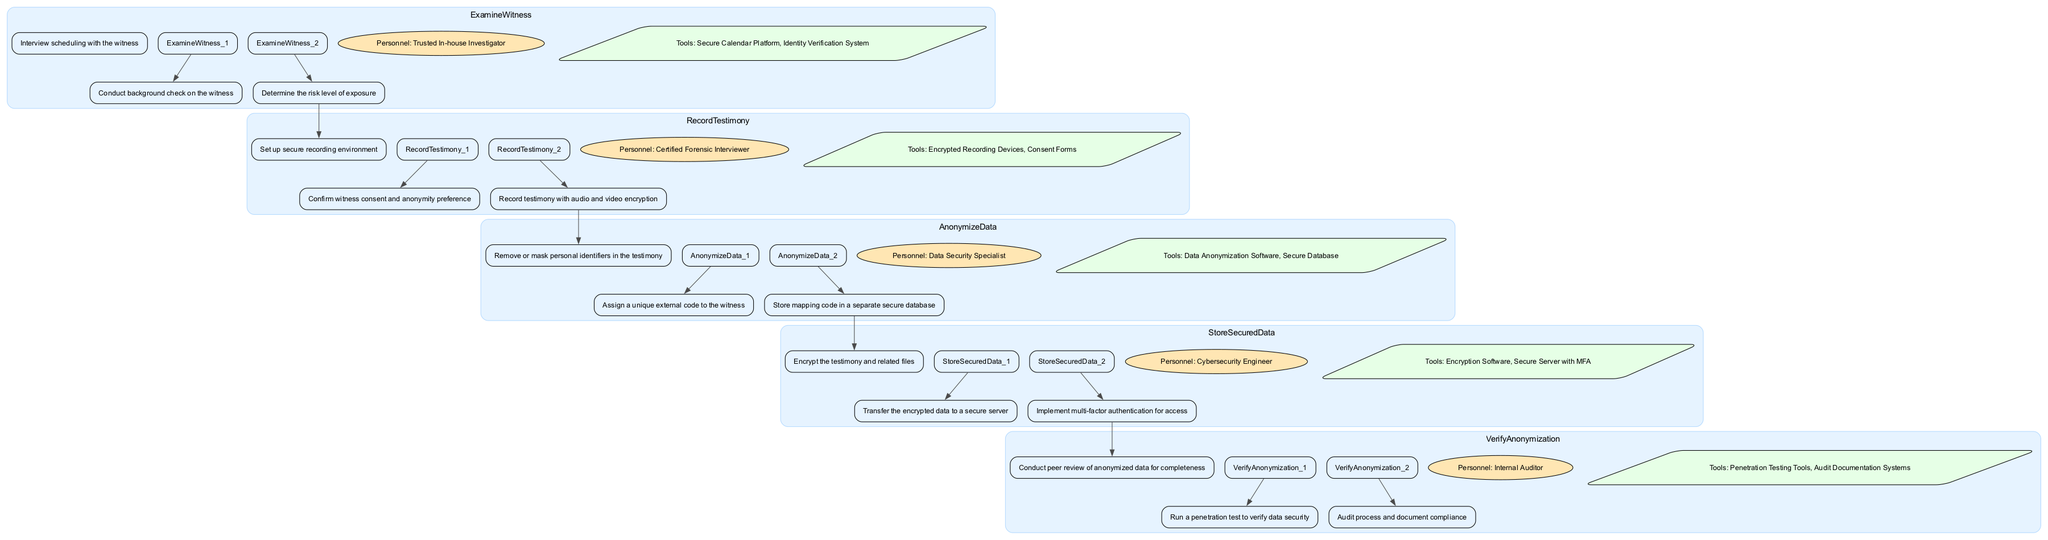What is the first step in the "ExamineWitness" process? The first step is explicitly listed as "Interview scheduling with the witness" under the "ExamineWitness" section of the diagram.
Answer: Interview scheduling with the witness Who conducts the background check on the witness? The "Personnel" node in the "ExamineWitness" section indicates that a "Trusted In-house Investigator" is responsible for conducting the background check on the witness.
Answer: Trusted In-house Investigator How many steps are in the "RecordTestimony" process? The "RecordTestimony" section lists three steps: "Set up secure recording environment," "Confirm witness consent and anonymity preference," and "Record testimony with audio and video encryption," indicating a total of three steps.
Answer: 3 Which personnel is responsible for anonymizing the data? In the "AnonymizeData" section of the diagram, it specifies that the "Data Security Specialist" is the personnel responsible for anonymizing the data.
Answer: Data Security Specialist What is the last step in the "StoreSecuredData" process? The last step in the "StoreSecuredData" process is noted as "Implement multi-factor authentication for access," which is the final step listed in that section.
Answer: Implement multi-factor authentication for access What connects the "AnonymizeData" process to the "StoreSecuredData" process? The diagram shows that the last step of the "AnonymizeData" process directly connects to the first step of the "StoreSecuredData" process, creating a flow between them.
Answer: Transition from anonymization to storage Which tool is used for encrypting the testimony and related files? The "Tools" node in the "StoreSecuredData" section identifies "Encryption Software" as one of the tools used for encrypting the testimony and related files.
Answer: Encryption Software How many unique processes are depicted in the diagram? The diagram highlights five distinct processes: "ExamineWitness," "RecordTestimony," "AnonymizeData," "StoreSecuredData," and "VerifyAnonymization," making a total of five processes.
Answer: 5 